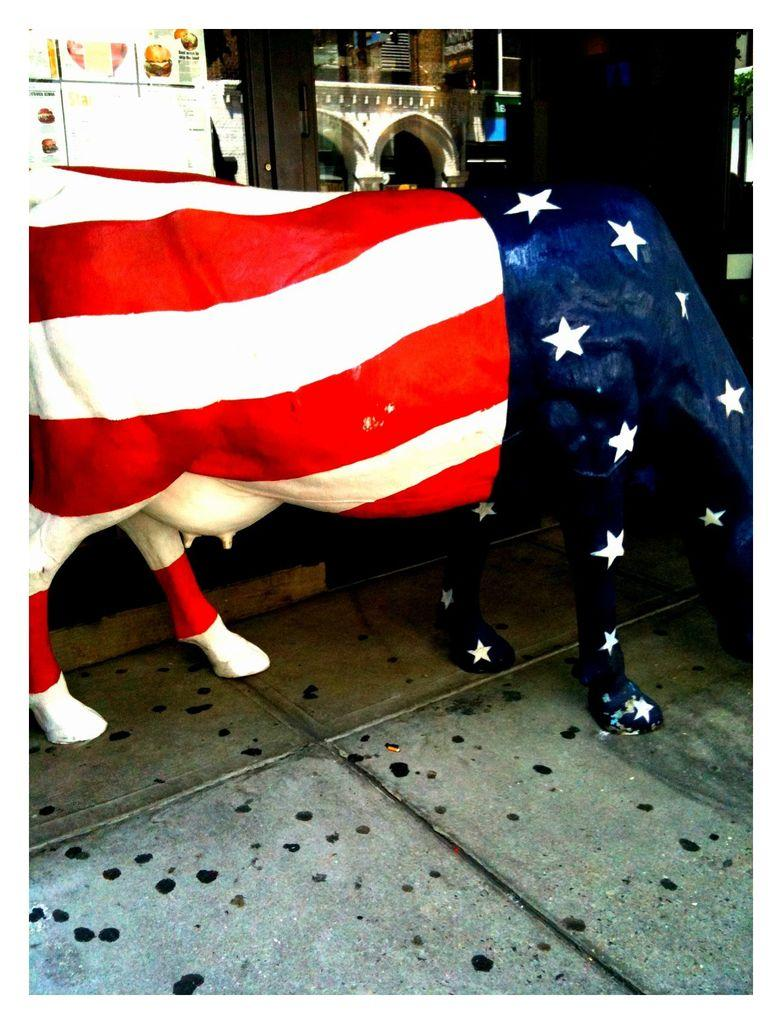What is the main subject in the middle of the image? There is an animal sculpture in the middle of the image. Can you describe the appearance of the animal sculpture? The animal sculpture is colored. What is at the bottom of the image? There is a floor at the bottom of the image. What can be seen in the background of the image? There is a building, a door, glass, and posters in the background of the image. What type of fiction is the deer reading in the image? There is no deer or any reading material present in the image. Can you tell me how many firemen are visible in the image? There are no firemen present in the image. 